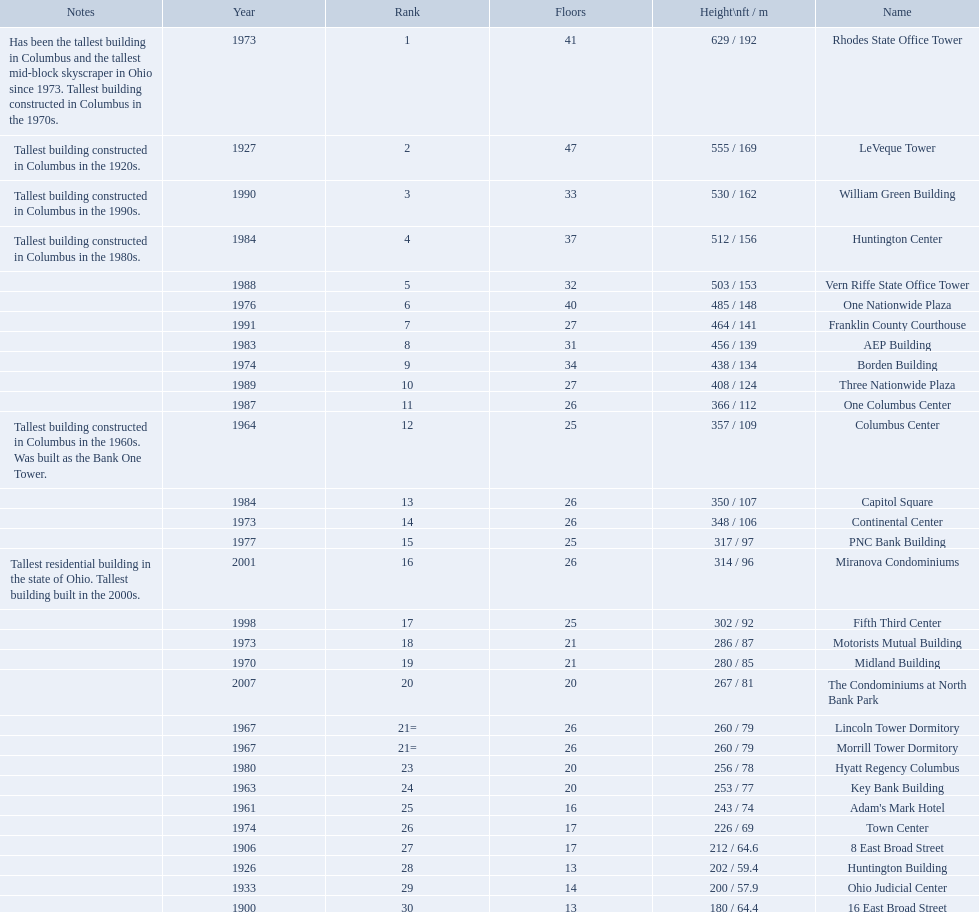What are the heights of all the buildings 629 / 192, 555 / 169, 530 / 162, 512 / 156, 503 / 153, 485 / 148, 464 / 141, 456 / 139, 438 / 134, 408 / 124, 366 / 112, 357 / 109, 350 / 107, 348 / 106, 317 / 97, 314 / 96, 302 / 92, 286 / 87, 280 / 85, 267 / 81, 260 / 79, 260 / 79, 256 / 78, 253 / 77, 243 / 74, 226 / 69, 212 / 64.6, 202 / 59.4, 200 / 57.9, 180 / 64.4. What are the heights of the aep and columbus center buildings 456 / 139, 357 / 109. Which height is greater? 456 / 139. What building is this for? AEP Building. 